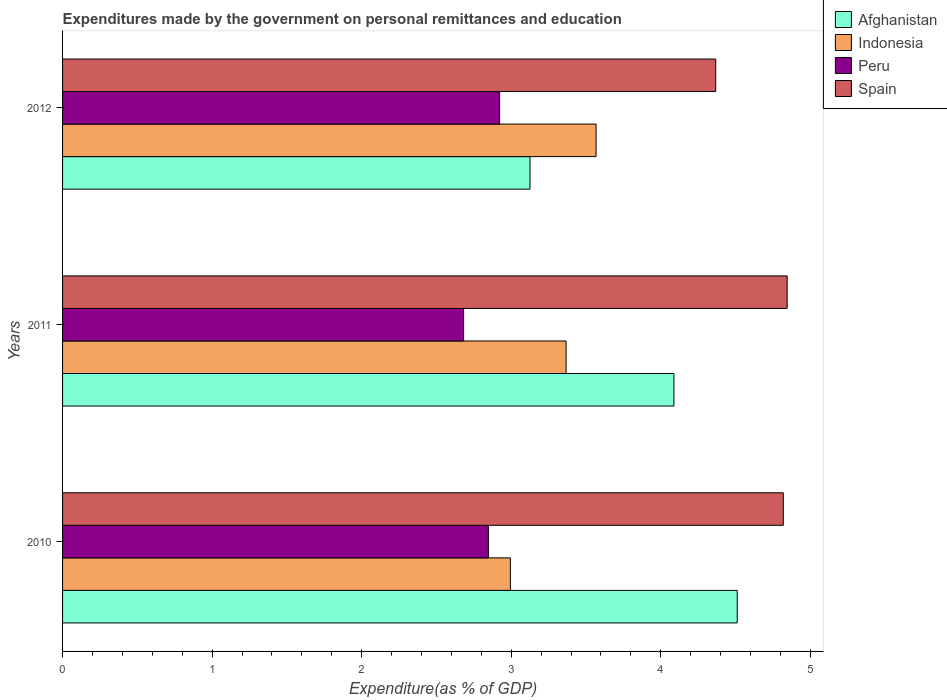What is the expenditures made by the government on personal remittances and education in Spain in 2011?
Make the answer very short. 4.85. Across all years, what is the maximum expenditures made by the government on personal remittances and education in Indonesia?
Ensure brevity in your answer.  3.57. Across all years, what is the minimum expenditures made by the government on personal remittances and education in Peru?
Ensure brevity in your answer.  2.68. What is the total expenditures made by the government on personal remittances and education in Spain in the graph?
Ensure brevity in your answer.  14.03. What is the difference between the expenditures made by the government on personal remittances and education in Spain in 2010 and that in 2012?
Make the answer very short. 0.45. What is the difference between the expenditures made by the government on personal remittances and education in Spain in 2010 and the expenditures made by the government on personal remittances and education in Peru in 2012?
Your answer should be compact. 1.9. What is the average expenditures made by the government on personal remittances and education in Spain per year?
Your answer should be very brief. 4.68. In the year 2011, what is the difference between the expenditures made by the government on personal remittances and education in Afghanistan and expenditures made by the government on personal remittances and education in Spain?
Your response must be concise. -0.76. In how many years, is the expenditures made by the government on personal remittances and education in Spain greater than 1.8 %?
Your answer should be very brief. 3. What is the ratio of the expenditures made by the government on personal remittances and education in Spain in 2011 to that in 2012?
Keep it short and to the point. 1.11. Is the expenditures made by the government on personal remittances and education in Afghanistan in 2010 less than that in 2011?
Give a very brief answer. No. Is the difference between the expenditures made by the government on personal remittances and education in Afghanistan in 2011 and 2012 greater than the difference between the expenditures made by the government on personal remittances and education in Spain in 2011 and 2012?
Your response must be concise. Yes. What is the difference between the highest and the second highest expenditures made by the government on personal remittances and education in Peru?
Your answer should be very brief. 0.07. What is the difference between the highest and the lowest expenditures made by the government on personal remittances and education in Afghanistan?
Give a very brief answer. 1.39. In how many years, is the expenditures made by the government on personal remittances and education in Indonesia greater than the average expenditures made by the government on personal remittances and education in Indonesia taken over all years?
Offer a very short reply. 2. Is the sum of the expenditures made by the government on personal remittances and education in Indonesia in 2011 and 2012 greater than the maximum expenditures made by the government on personal remittances and education in Peru across all years?
Offer a very short reply. Yes. What does the 2nd bar from the bottom in 2010 represents?
Provide a short and direct response. Indonesia. Is it the case that in every year, the sum of the expenditures made by the government on personal remittances and education in Afghanistan and expenditures made by the government on personal remittances and education in Peru is greater than the expenditures made by the government on personal remittances and education in Indonesia?
Offer a very short reply. Yes. Are all the bars in the graph horizontal?
Provide a short and direct response. Yes. Are the values on the major ticks of X-axis written in scientific E-notation?
Provide a short and direct response. No. Does the graph contain any zero values?
Your response must be concise. No. Does the graph contain grids?
Ensure brevity in your answer.  No. What is the title of the graph?
Ensure brevity in your answer.  Expenditures made by the government on personal remittances and education. Does "Argentina" appear as one of the legend labels in the graph?
Your answer should be very brief. No. What is the label or title of the X-axis?
Provide a succinct answer. Expenditure(as % of GDP). What is the label or title of the Y-axis?
Provide a succinct answer. Years. What is the Expenditure(as % of GDP) of Afghanistan in 2010?
Provide a short and direct response. 4.51. What is the Expenditure(as % of GDP) in Indonesia in 2010?
Offer a very short reply. 2.99. What is the Expenditure(as % of GDP) in Peru in 2010?
Your response must be concise. 2.85. What is the Expenditure(as % of GDP) of Spain in 2010?
Give a very brief answer. 4.82. What is the Expenditure(as % of GDP) of Afghanistan in 2011?
Your answer should be compact. 4.09. What is the Expenditure(as % of GDP) of Indonesia in 2011?
Make the answer very short. 3.37. What is the Expenditure(as % of GDP) in Peru in 2011?
Offer a very short reply. 2.68. What is the Expenditure(as % of GDP) of Spain in 2011?
Offer a very short reply. 4.85. What is the Expenditure(as % of GDP) in Afghanistan in 2012?
Give a very brief answer. 3.13. What is the Expenditure(as % of GDP) of Indonesia in 2012?
Ensure brevity in your answer.  3.57. What is the Expenditure(as % of GDP) of Peru in 2012?
Offer a very short reply. 2.92. What is the Expenditure(as % of GDP) in Spain in 2012?
Ensure brevity in your answer.  4.37. Across all years, what is the maximum Expenditure(as % of GDP) of Afghanistan?
Provide a succinct answer. 4.51. Across all years, what is the maximum Expenditure(as % of GDP) in Indonesia?
Your response must be concise. 3.57. Across all years, what is the maximum Expenditure(as % of GDP) in Peru?
Give a very brief answer. 2.92. Across all years, what is the maximum Expenditure(as % of GDP) in Spain?
Offer a very short reply. 4.85. Across all years, what is the minimum Expenditure(as % of GDP) in Afghanistan?
Provide a short and direct response. 3.13. Across all years, what is the minimum Expenditure(as % of GDP) in Indonesia?
Your response must be concise. 2.99. Across all years, what is the minimum Expenditure(as % of GDP) in Peru?
Your answer should be very brief. 2.68. Across all years, what is the minimum Expenditure(as % of GDP) in Spain?
Provide a short and direct response. 4.37. What is the total Expenditure(as % of GDP) of Afghanistan in the graph?
Your response must be concise. 11.72. What is the total Expenditure(as % of GDP) of Indonesia in the graph?
Make the answer very short. 9.93. What is the total Expenditure(as % of GDP) in Peru in the graph?
Your answer should be very brief. 8.45. What is the total Expenditure(as % of GDP) of Spain in the graph?
Your answer should be very brief. 14.03. What is the difference between the Expenditure(as % of GDP) in Afghanistan in 2010 and that in 2011?
Provide a short and direct response. 0.42. What is the difference between the Expenditure(as % of GDP) of Indonesia in 2010 and that in 2011?
Your response must be concise. -0.37. What is the difference between the Expenditure(as % of GDP) in Peru in 2010 and that in 2011?
Your answer should be very brief. 0.17. What is the difference between the Expenditure(as % of GDP) of Spain in 2010 and that in 2011?
Keep it short and to the point. -0.03. What is the difference between the Expenditure(as % of GDP) in Afghanistan in 2010 and that in 2012?
Make the answer very short. 1.39. What is the difference between the Expenditure(as % of GDP) of Indonesia in 2010 and that in 2012?
Give a very brief answer. -0.57. What is the difference between the Expenditure(as % of GDP) in Peru in 2010 and that in 2012?
Offer a very short reply. -0.07. What is the difference between the Expenditure(as % of GDP) of Spain in 2010 and that in 2012?
Keep it short and to the point. 0.45. What is the difference between the Expenditure(as % of GDP) in Afghanistan in 2011 and that in 2012?
Give a very brief answer. 0.96. What is the difference between the Expenditure(as % of GDP) in Indonesia in 2011 and that in 2012?
Offer a very short reply. -0.2. What is the difference between the Expenditure(as % of GDP) of Peru in 2011 and that in 2012?
Provide a short and direct response. -0.24. What is the difference between the Expenditure(as % of GDP) of Spain in 2011 and that in 2012?
Your answer should be compact. 0.48. What is the difference between the Expenditure(as % of GDP) of Afghanistan in 2010 and the Expenditure(as % of GDP) of Indonesia in 2011?
Your answer should be very brief. 1.14. What is the difference between the Expenditure(as % of GDP) of Afghanistan in 2010 and the Expenditure(as % of GDP) of Peru in 2011?
Make the answer very short. 1.83. What is the difference between the Expenditure(as % of GDP) in Afghanistan in 2010 and the Expenditure(as % of GDP) in Spain in 2011?
Ensure brevity in your answer.  -0.33. What is the difference between the Expenditure(as % of GDP) of Indonesia in 2010 and the Expenditure(as % of GDP) of Peru in 2011?
Make the answer very short. 0.31. What is the difference between the Expenditure(as % of GDP) in Indonesia in 2010 and the Expenditure(as % of GDP) in Spain in 2011?
Offer a terse response. -1.85. What is the difference between the Expenditure(as % of GDP) of Peru in 2010 and the Expenditure(as % of GDP) of Spain in 2011?
Give a very brief answer. -2. What is the difference between the Expenditure(as % of GDP) of Afghanistan in 2010 and the Expenditure(as % of GDP) of Indonesia in 2012?
Provide a succinct answer. 0.94. What is the difference between the Expenditure(as % of GDP) of Afghanistan in 2010 and the Expenditure(as % of GDP) of Peru in 2012?
Your response must be concise. 1.59. What is the difference between the Expenditure(as % of GDP) in Afghanistan in 2010 and the Expenditure(as % of GDP) in Spain in 2012?
Ensure brevity in your answer.  0.14. What is the difference between the Expenditure(as % of GDP) of Indonesia in 2010 and the Expenditure(as % of GDP) of Peru in 2012?
Your answer should be very brief. 0.07. What is the difference between the Expenditure(as % of GDP) of Indonesia in 2010 and the Expenditure(as % of GDP) of Spain in 2012?
Provide a short and direct response. -1.37. What is the difference between the Expenditure(as % of GDP) in Peru in 2010 and the Expenditure(as % of GDP) in Spain in 2012?
Give a very brief answer. -1.52. What is the difference between the Expenditure(as % of GDP) of Afghanistan in 2011 and the Expenditure(as % of GDP) of Indonesia in 2012?
Your response must be concise. 0.52. What is the difference between the Expenditure(as % of GDP) in Afghanistan in 2011 and the Expenditure(as % of GDP) in Peru in 2012?
Give a very brief answer. 1.17. What is the difference between the Expenditure(as % of GDP) of Afghanistan in 2011 and the Expenditure(as % of GDP) of Spain in 2012?
Make the answer very short. -0.28. What is the difference between the Expenditure(as % of GDP) of Indonesia in 2011 and the Expenditure(as % of GDP) of Peru in 2012?
Provide a short and direct response. 0.44. What is the difference between the Expenditure(as % of GDP) of Indonesia in 2011 and the Expenditure(as % of GDP) of Spain in 2012?
Offer a terse response. -1. What is the difference between the Expenditure(as % of GDP) of Peru in 2011 and the Expenditure(as % of GDP) of Spain in 2012?
Ensure brevity in your answer.  -1.69. What is the average Expenditure(as % of GDP) of Afghanistan per year?
Your answer should be very brief. 3.91. What is the average Expenditure(as % of GDP) of Indonesia per year?
Provide a short and direct response. 3.31. What is the average Expenditure(as % of GDP) in Peru per year?
Provide a short and direct response. 2.82. What is the average Expenditure(as % of GDP) in Spain per year?
Your answer should be compact. 4.68. In the year 2010, what is the difference between the Expenditure(as % of GDP) in Afghanistan and Expenditure(as % of GDP) in Indonesia?
Your answer should be very brief. 1.52. In the year 2010, what is the difference between the Expenditure(as % of GDP) in Afghanistan and Expenditure(as % of GDP) in Peru?
Provide a short and direct response. 1.66. In the year 2010, what is the difference between the Expenditure(as % of GDP) in Afghanistan and Expenditure(as % of GDP) in Spain?
Provide a short and direct response. -0.31. In the year 2010, what is the difference between the Expenditure(as % of GDP) of Indonesia and Expenditure(as % of GDP) of Peru?
Provide a short and direct response. 0.15. In the year 2010, what is the difference between the Expenditure(as % of GDP) of Indonesia and Expenditure(as % of GDP) of Spain?
Give a very brief answer. -1.82. In the year 2010, what is the difference between the Expenditure(as % of GDP) of Peru and Expenditure(as % of GDP) of Spain?
Provide a short and direct response. -1.97. In the year 2011, what is the difference between the Expenditure(as % of GDP) of Afghanistan and Expenditure(as % of GDP) of Indonesia?
Offer a very short reply. 0.72. In the year 2011, what is the difference between the Expenditure(as % of GDP) in Afghanistan and Expenditure(as % of GDP) in Peru?
Offer a terse response. 1.41. In the year 2011, what is the difference between the Expenditure(as % of GDP) in Afghanistan and Expenditure(as % of GDP) in Spain?
Your response must be concise. -0.76. In the year 2011, what is the difference between the Expenditure(as % of GDP) in Indonesia and Expenditure(as % of GDP) in Peru?
Offer a very short reply. 0.69. In the year 2011, what is the difference between the Expenditure(as % of GDP) of Indonesia and Expenditure(as % of GDP) of Spain?
Give a very brief answer. -1.48. In the year 2011, what is the difference between the Expenditure(as % of GDP) in Peru and Expenditure(as % of GDP) in Spain?
Give a very brief answer. -2.16. In the year 2012, what is the difference between the Expenditure(as % of GDP) of Afghanistan and Expenditure(as % of GDP) of Indonesia?
Make the answer very short. -0.44. In the year 2012, what is the difference between the Expenditure(as % of GDP) in Afghanistan and Expenditure(as % of GDP) in Peru?
Offer a terse response. 0.2. In the year 2012, what is the difference between the Expenditure(as % of GDP) in Afghanistan and Expenditure(as % of GDP) in Spain?
Offer a very short reply. -1.24. In the year 2012, what is the difference between the Expenditure(as % of GDP) in Indonesia and Expenditure(as % of GDP) in Peru?
Offer a terse response. 0.65. In the year 2012, what is the difference between the Expenditure(as % of GDP) of Peru and Expenditure(as % of GDP) of Spain?
Your answer should be compact. -1.45. What is the ratio of the Expenditure(as % of GDP) of Afghanistan in 2010 to that in 2011?
Your answer should be compact. 1.1. What is the ratio of the Expenditure(as % of GDP) in Indonesia in 2010 to that in 2011?
Provide a succinct answer. 0.89. What is the ratio of the Expenditure(as % of GDP) of Peru in 2010 to that in 2011?
Provide a short and direct response. 1.06. What is the ratio of the Expenditure(as % of GDP) of Spain in 2010 to that in 2011?
Keep it short and to the point. 0.99. What is the ratio of the Expenditure(as % of GDP) of Afghanistan in 2010 to that in 2012?
Keep it short and to the point. 1.44. What is the ratio of the Expenditure(as % of GDP) in Indonesia in 2010 to that in 2012?
Your answer should be very brief. 0.84. What is the ratio of the Expenditure(as % of GDP) in Peru in 2010 to that in 2012?
Make the answer very short. 0.97. What is the ratio of the Expenditure(as % of GDP) in Spain in 2010 to that in 2012?
Your answer should be very brief. 1.1. What is the ratio of the Expenditure(as % of GDP) of Afghanistan in 2011 to that in 2012?
Keep it short and to the point. 1.31. What is the ratio of the Expenditure(as % of GDP) in Indonesia in 2011 to that in 2012?
Your answer should be compact. 0.94. What is the ratio of the Expenditure(as % of GDP) in Peru in 2011 to that in 2012?
Your response must be concise. 0.92. What is the ratio of the Expenditure(as % of GDP) of Spain in 2011 to that in 2012?
Keep it short and to the point. 1.11. What is the difference between the highest and the second highest Expenditure(as % of GDP) in Afghanistan?
Give a very brief answer. 0.42. What is the difference between the highest and the second highest Expenditure(as % of GDP) in Indonesia?
Your answer should be compact. 0.2. What is the difference between the highest and the second highest Expenditure(as % of GDP) in Peru?
Offer a very short reply. 0.07. What is the difference between the highest and the second highest Expenditure(as % of GDP) of Spain?
Make the answer very short. 0.03. What is the difference between the highest and the lowest Expenditure(as % of GDP) of Afghanistan?
Make the answer very short. 1.39. What is the difference between the highest and the lowest Expenditure(as % of GDP) of Indonesia?
Provide a short and direct response. 0.57. What is the difference between the highest and the lowest Expenditure(as % of GDP) of Peru?
Offer a very short reply. 0.24. What is the difference between the highest and the lowest Expenditure(as % of GDP) of Spain?
Your response must be concise. 0.48. 